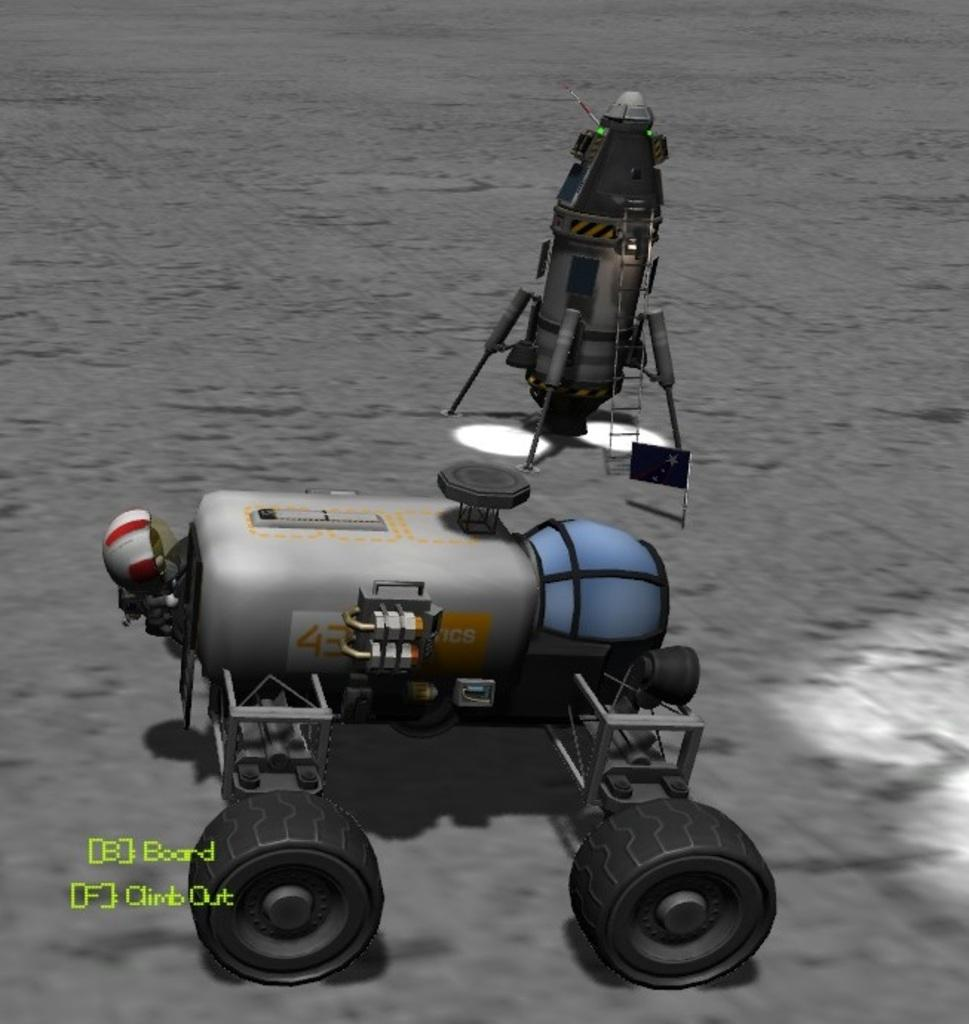<image>
Describe the image concisely. A CGI image of a buggy with the number 43 on it 